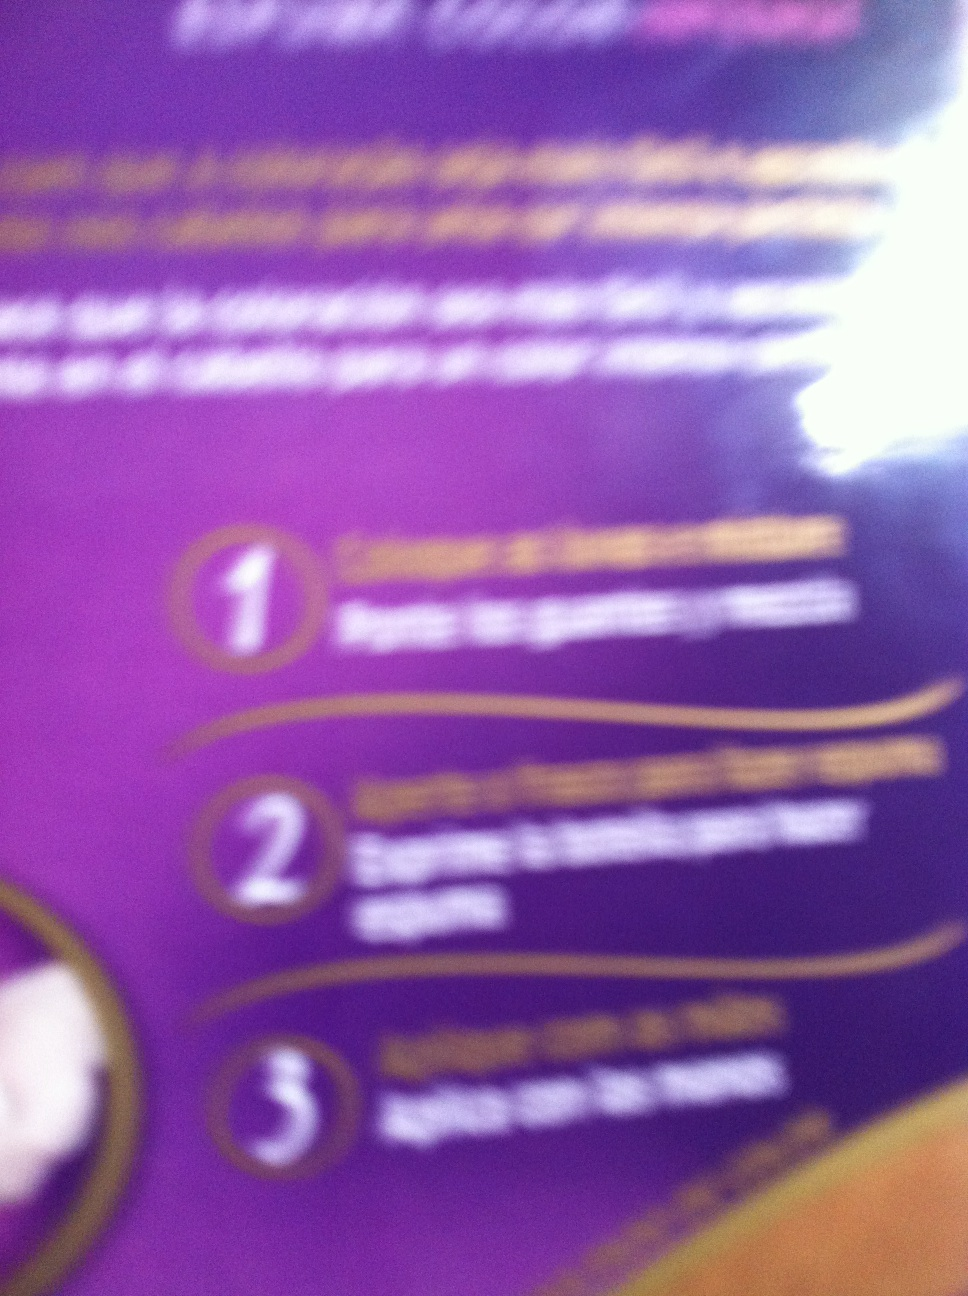This picture is a bit unclear, but can you guess what the instructions are about? From what I can see, the instructions seem to be for a skincare or personal care product. It generally involves applying the product to the skin, spreading it evenly, and ensuring it is fully absorbed. This type of routine is common for lotions, creams, or serums. 